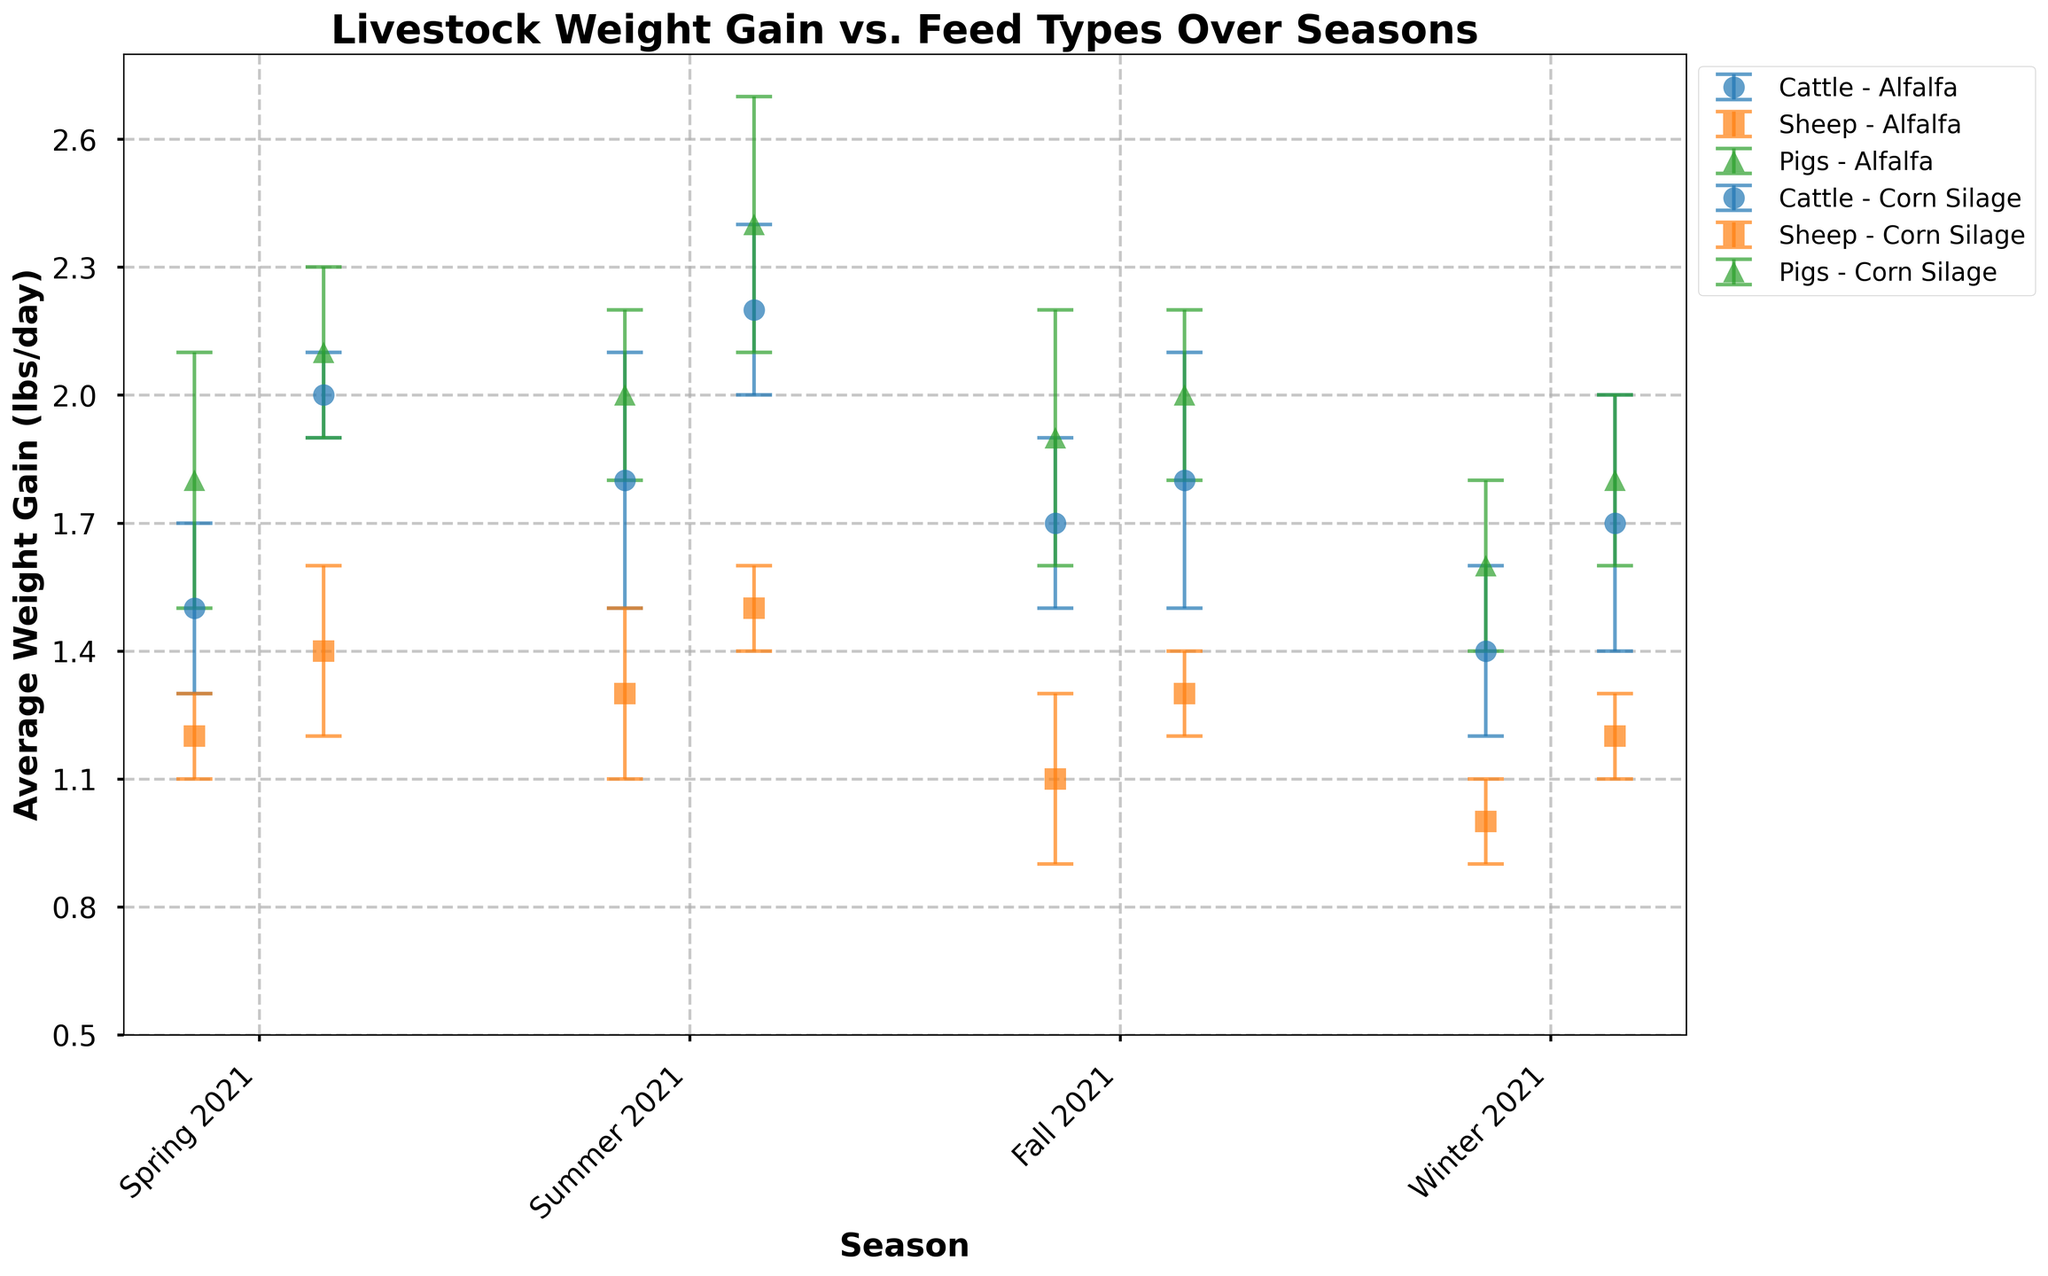Which Feed Type shows the highest average weight gain for Pigs in Summer 2021? Look for the marker symbol representing Pigs (triangles) in Summer 2021 data points. Compare the weight gain values for Alfalfa and Corn Silage. Corn Silage shows a higher average (2.4 lbs/day) compared to Alfalfa (2.0 lbs/day).
Answer: Corn Silage How does Winter 2021 compare to Spring 2021 in terms of average weight gain for Cattle on Alfalfa? Compare the weight gain values for Cattle on Alfalfa in Winter 2021 (1.4 lbs/day) and Spring 2021 (1.5 lbs/day). Subtract Winter 2021 value from Spring 2021 value to get the difference (1.5 - 1.4 = 0.1 lbs/day).
Answer: Decreased by 0.1 lbs/day What is the highest average weight gain recorded for Sheep, and during which season and feed type did it occur? Find the highest value among Sheep (square markers) across all seasons and feed types. Sheep on Corn Silage in Summer 2021 has the highest average weight gain (1.5 lbs/day).
Answer: 1.5 lbs/day during Summer 2021 on Corn Silage Which season reports the lowest average weight gain for Alfalfa-fed Sheep? Compare the weight gain values for Sheep fed Alfalfa across all seasons. Winter 2021 shows the lowest value (1.0 lbs/day).
Answer: Winter 2021 Between Corn Silage and Alfalfa, which feed type shows less variability in weight gain for Cattle during Spring 2021? Compare the standard deviation (error bars) in weight gain for Cattle in Spring 2021 on both feed types. Corn Silage shows 0.1 lbs/day, which is less than Alfalfa (0.2 lbs/day).
Answer: Corn Silage What is the total number of data points shown in the figure? Count the number of unique combinations of Season, Feed Type, and Livestock Type plotted on the figure. There are 24 such combinations (4 seasons × 2 feed types × 3 livestock types).
Answer: 24 Which livestock type shows the most consistent weight gain (least variability) over all seasons when fed Alfalfa? Compare the size and consistency (smallest error bars) across all seasons for each livestock type fed Alfalfa. Sheep shows the least variability with smaller error bars compared to Cattle and Pigs.
Answer: Sheep What is the range of the average weight gain for Corn Silage-fed Cattle across all seasons? Identify the minimum and maximum values of average weight gain for Corn Silage-fed Cattle across all seasons. The range is calculated as the difference between the maximum (2.2 lbs/day in Summer 2021) and minimum (1.7 lbs/day in Winter 2021).
Answer: 0.5 lbs/day Which livestock type has the highest increase in weight gain from Fall 2021 to Winter 2021 when fed Corn Silage? Compare the weight gain values for each livestock type on Corn Silage from Fall (Cattle: 1.8 lbs/day, Sheep: 1.3 lbs/day, Pigs: 2.0 lbs/day) to Winter (Cattle: 1.7 lbs/day, Sheep: 1.2 lbs/day, Pigs: 1.8 lbs/day). Calculate the decrease for each (Cattle: -0.1, Sheep: -0.1, Pigs: -0.2). Find the highest decrease, which is in Pigs.
Answer: Sheep How does the average weight gain for Pigs on Alfalfa in Winter 2021 compare to Corn Silage in the same season? Compare the weight gain values for Pigs fed Alfalfa (1.6 lbs/day) and Corn Silage (1.8 lbs/day) in Winter 2021.
Answer: Corn Silage is higher by 0.2 lbs/day 